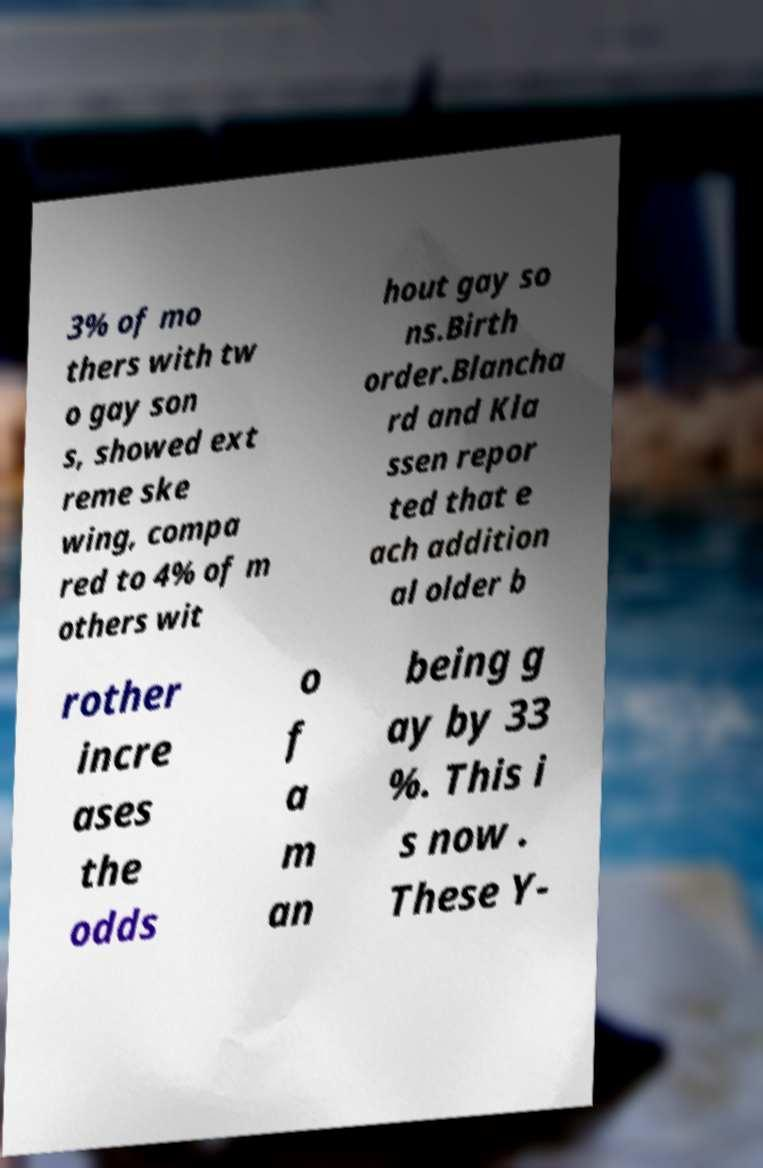There's text embedded in this image that I need extracted. Can you transcribe it verbatim? 3% of mo thers with tw o gay son s, showed ext reme ske wing, compa red to 4% of m others wit hout gay so ns.Birth order.Blancha rd and Kla ssen repor ted that e ach addition al older b rother incre ases the odds o f a m an being g ay by 33 %. This i s now . These Y- 